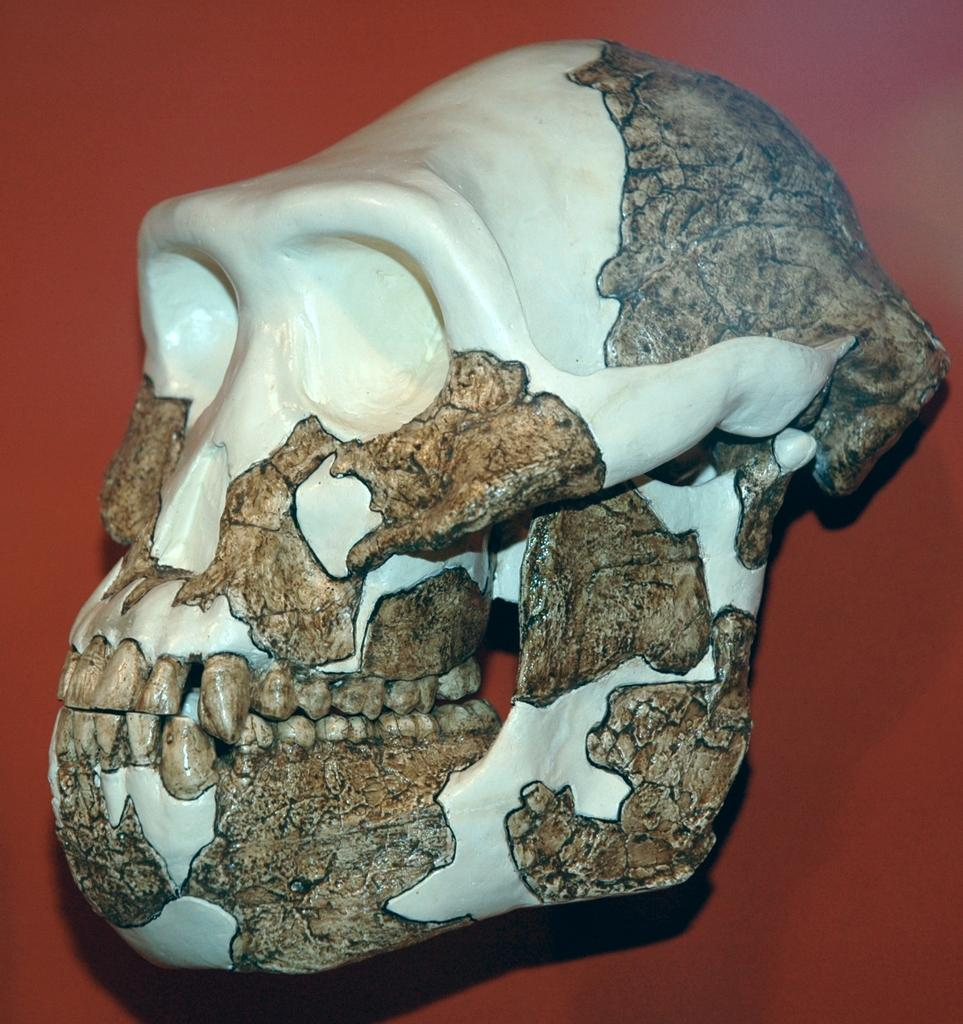What is the main subject of the image? The main subject of the image is a skull. Can you describe any specific features of the skull? Yes, the skull has teeth. What type of pancake is being cooked in the image? There is no pancake present in the image; it features a skull with teeth. 